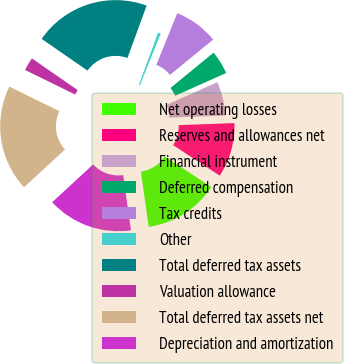Convert chart to OTSL. <chart><loc_0><loc_0><loc_500><loc_500><pie_chart><fcel>Net operating losses<fcel>Reserves and allowances net<fcel>Financial instrument<fcel>Deferred compensation<fcel>Tax credits<fcel>Other<fcel>Total deferred tax assets<fcel>Valuation allowance<fcel>Total deferred tax assets net<fcel>Depreciation and amortization<nl><fcel>13.53%<fcel>9.81%<fcel>6.1%<fcel>4.24%<fcel>7.96%<fcel>0.52%<fcel>20.96%<fcel>2.38%<fcel>19.11%<fcel>15.39%<nl></chart> 